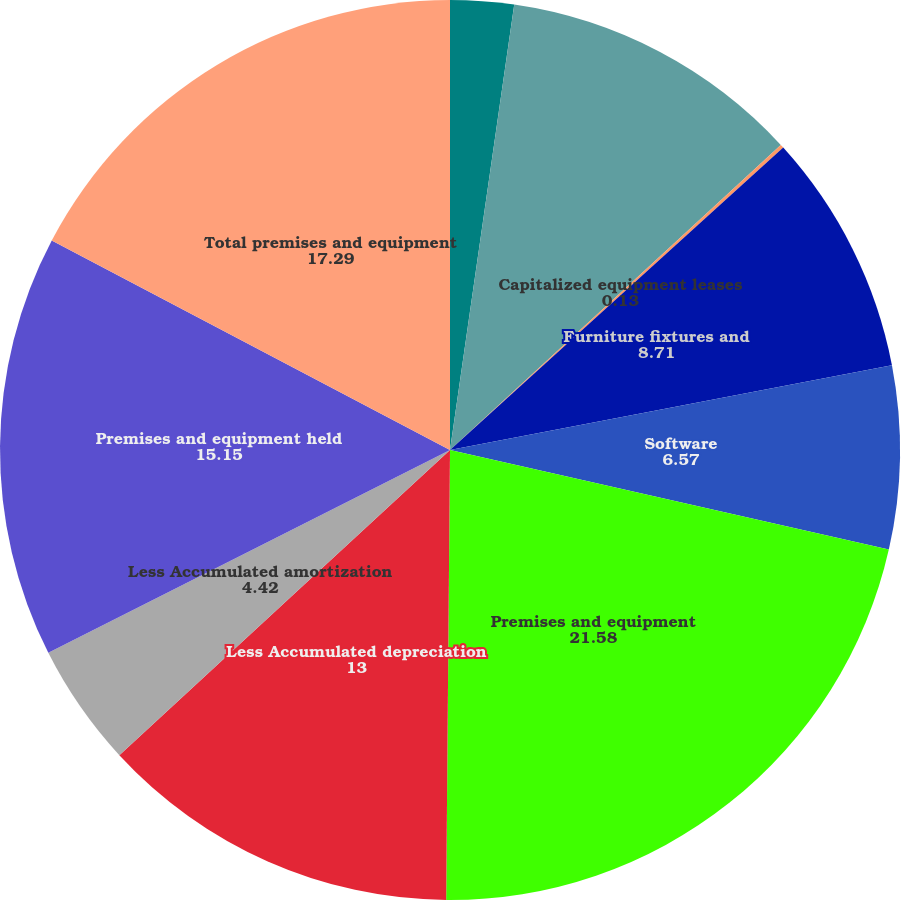Convert chart. <chart><loc_0><loc_0><loc_500><loc_500><pie_chart><fcel>Land<fcel>Buildings and improvements<fcel>Capitalized equipment leases<fcel>Furniture fixtures and<fcel>Software<fcel>Premises and equipment<fcel>Less Accumulated depreciation<fcel>Less Accumulated amortization<fcel>Premises and equipment held<fcel>Total premises and equipment<nl><fcel>2.28%<fcel>10.86%<fcel>0.13%<fcel>8.71%<fcel>6.57%<fcel>21.58%<fcel>13.0%<fcel>4.42%<fcel>15.15%<fcel>17.29%<nl></chart> 